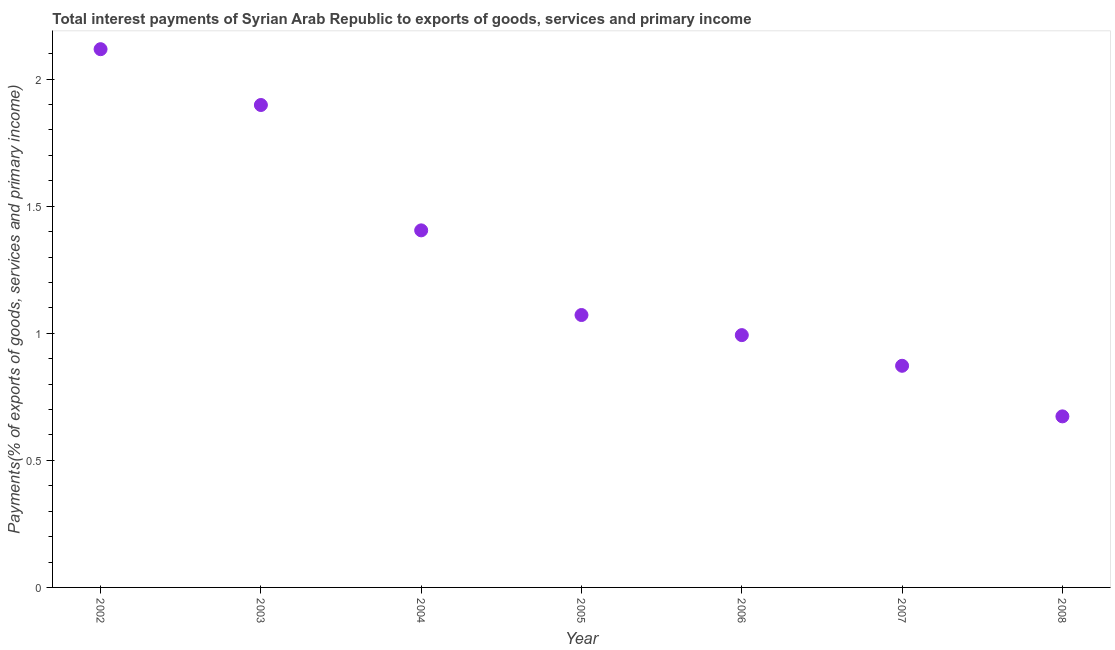What is the total interest payments on external debt in 2005?
Keep it short and to the point. 1.07. Across all years, what is the maximum total interest payments on external debt?
Your response must be concise. 2.12. Across all years, what is the minimum total interest payments on external debt?
Give a very brief answer. 0.67. What is the sum of the total interest payments on external debt?
Give a very brief answer. 9.03. What is the difference between the total interest payments on external debt in 2004 and 2006?
Your response must be concise. 0.41. What is the average total interest payments on external debt per year?
Give a very brief answer. 1.29. What is the median total interest payments on external debt?
Offer a very short reply. 1.07. In how many years, is the total interest payments on external debt greater than 0.9 %?
Keep it short and to the point. 5. Do a majority of the years between 2002 and 2008 (inclusive) have total interest payments on external debt greater than 1.9 %?
Your answer should be compact. No. What is the ratio of the total interest payments on external debt in 2002 to that in 2007?
Give a very brief answer. 2.43. What is the difference between the highest and the second highest total interest payments on external debt?
Your answer should be compact. 0.22. Is the sum of the total interest payments on external debt in 2005 and 2008 greater than the maximum total interest payments on external debt across all years?
Offer a terse response. No. What is the difference between the highest and the lowest total interest payments on external debt?
Ensure brevity in your answer.  1.44. In how many years, is the total interest payments on external debt greater than the average total interest payments on external debt taken over all years?
Ensure brevity in your answer.  3. What is the difference between two consecutive major ticks on the Y-axis?
Ensure brevity in your answer.  0.5. Are the values on the major ticks of Y-axis written in scientific E-notation?
Your answer should be very brief. No. Does the graph contain any zero values?
Offer a terse response. No. Does the graph contain grids?
Your response must be concise. No. What is the title of the graph?
Offer a terse response. Total interest payments of Syrian Arab Republic to exports of goods, services and primary income. What is the label or title of the Y-axis?
Your answer should be compact. Payments(% of exports of goods, services and primary income). What is the Payments(% of exports of goods, services and primary income) in 2002?
Your answer should be compact. 2.12. What is the Payments(% of exports of goods, services and primary income) in 2003?
Ensure brevity in your answer.  1.9. What is the Payments(% of exports of goods, services and primary income) in 2004?
Offer a very short reply. 1.4. What is the Payments(% of exports of goods, services and primary income) in 2005?
Make the answer very short. 1.07. What is the Payments(% of exports of goods, services and primary income) in 2006?
Give a very brief answer. 0.99. What is the Payments(% of exports of goods, services and primary income) in 2007?
Keep it short and to the point. 0.87. What is the Payments(% of exports of goods, services and primary income) in 2008?
Make the answer very short. 0.67. What is the difference between the Payments(% of exports of goods, services and primary income) in 2002 and 2003?
Give a very brief answer. 0.22. What is the difference between the Payments(% of exports of goods, services and primary income) in 2002 and 2004?
Make the answer very short. 0.71. What is the difference between the Payments(% of exports of goods, services and primary income) in 2002 and 2005?
Offer a very short reply. 1.05. What is the difference between the Payments(% of exports of goods, services and primary income) in 2002 and 2006?
Your response must be concise. 1.12. What is the difference between the Payments(% of exports of goods, services and primary income) in 2002 and 2007?
Your answer should be compact. 1.25. What is the difference between the Payments(% of exports of goods, services and primary income) in 2002 and 2008?
Your answer should be very brief. 1.44. What is the difference between the Payments(% of exports of goods, services and primary income) in 2003 and 2004?
Keep it short and to the point. 0.49. What is the difference between the Payments(% of exports of goods, services and primary income) in 2003 and 2005?
Provide a short and direct response. 0.83. What is the difference between the Payments(% of exports of goods, services and primary income) in 2003 and 2006?
Provide a succinct answer. 0.91. What is the difference between the Payments(% of exports of goods, services and primary income) in 2003 and 2007?
Make the answer very short. 1.03. What is the difference between the Payments(% of exports of goods, services and primary income) in 2003 and 2008?
Offer a very short reply. 1.23. What is the difference between the Payments(% of exports of goods, services and primary income) in 2004 and 2005?
Make the answer very short. 0.33. What is the difference between the Payments(% of exports of goods, services and primary income) in 2004 and 2006?
Provide a short and direct response. 0.41. What is the difference between the Payments(% of exports of goods, services and primary income) in 2004 and 2007?
Give a very brief answer. 0.53. What is the difference between the Payments(% of exports of goods, services and primary income) in 2004 and 2008?
Provide a succinct answer. 0.73. What is the difference between the Payments(% of exports of goods, services and primary income) in 2005 and 2006?
Offer a very short reply. 0.08. What is the difference between the Payments(% of exports of goods, services and primary income) in 2005 and 2007?
Your response must be concise. 0.2. What is the difference between the Payments(% of exports of goods, services and primary income) in 2005 and 2008?
Your answer should be compact. 0.4. What is the difference between the Payments(% of exports of goods, services and primary income) in 2006 and 2007?
Keep it short and to the point. 0.12. What is the difference between the Payments(% of exports of goods, services and primary income) in 2006 and 2008?
Keep it short and to the point. 0.32. What is the difference between the Payments(% of exports of goods, services and primary income) in 2007 and 2008?
Your answer should be very brief. 0.2. What is the ratio of the Payments(% of exports of goods, services and primary income) in 2002 to that in 2003?
Ensure brevity in your answer.  1.12. What is the ratio of the Payments(% of exports of goods, services and primary income) in 2002 to that in 2004?
Offer a very short reply. 1.51. What is the ratio of the Payments(% of exports of goods, services and primary income) in 2002 to that in 2005?
Offer a terse response. 1.98. What is the ratio of the Payments(% of exports of goods, services and primary income) in 2002 to that in 2006?
Your answer should be compact. 2.13. What is the ratio of the Payments(% of exports of goods, services and primary income) in 2002 to that in 2007?
Keep it short and to the point. 2.43. What is the ratio of the Payments(% of exports of goods, services and primary income) in 2002 to that in 2008?
Your answer should be very brief. 3.15. What is the ratio of the Payments(% of exports of goods, services and primary income) in 2003 to that in 2004?
Provide a short and direct response. 1.35. What is the ratio of the Payments(% of exports of goods, services and primary income) in 2003 to that in 2005?
Provide a short and direct response. 1.77. What is the ratio of the Payments(% of exports of goods, services and primary income) in 2003 to that in 2006?
Provide a succinct answer. 1.91. What is the ratio of the Payments(% of exports of goods, services and primary income) in 2003 to that in 2007?
Your answer should be compact. 2.18. What is the ratio of the Payments(% of exports of goods, services and primary income) in 2003 to that in 2008?
Ensure brevity in your answer.  2.82. What is the ratio of the Payments(% of exports of goods, services and primary income) in 2004 to that in 2005?
Provide a succinct answer. 1.31. What is the ratio of the Payments(% of exports of goods, services and primary income) in 2004 to that in 2006?
Provide a succinct answer. 1.42. What is the ratio of the Payments(% of exports of goods, services and primary income) in 2004 to that in 2007?
Give a very brief answer. 1.61. What is the ratio of the Payments(% of exports of goods, services and primary income) in 2004 to that in 2008?
Make the answer very short. 2.09. What is the ratio of the Payments(% of exports of goods, services and primary income) in 2005 to that in 2006?
Your answer should be very brief. 1.08. What is the ratio of the Payments(% of exports of goods, services and primary income) in 2005 to that in 2007?
Your answer should be very brief. 1.23. What is the ratio of the Payments(% of exports of goods, services and primary income) in 2005 to that in 2008?
Provide a succinct answer. 1.59. What is the ratio of the Payments(% of exports of goods, services and primary income) in 2006 to that in 2007?
Ensure brevity in your answer.  1.14. What is the ratio of the Payments(% of exports of goods, services and primary income) in 2006 to that in 2008?
Ensure brevity in your answer.  1.48. What is the ratio of the Payments(% of exports of goods, services and primary income) in 2007 to that in 2008?
Keep it short and to the point. 1.3. 